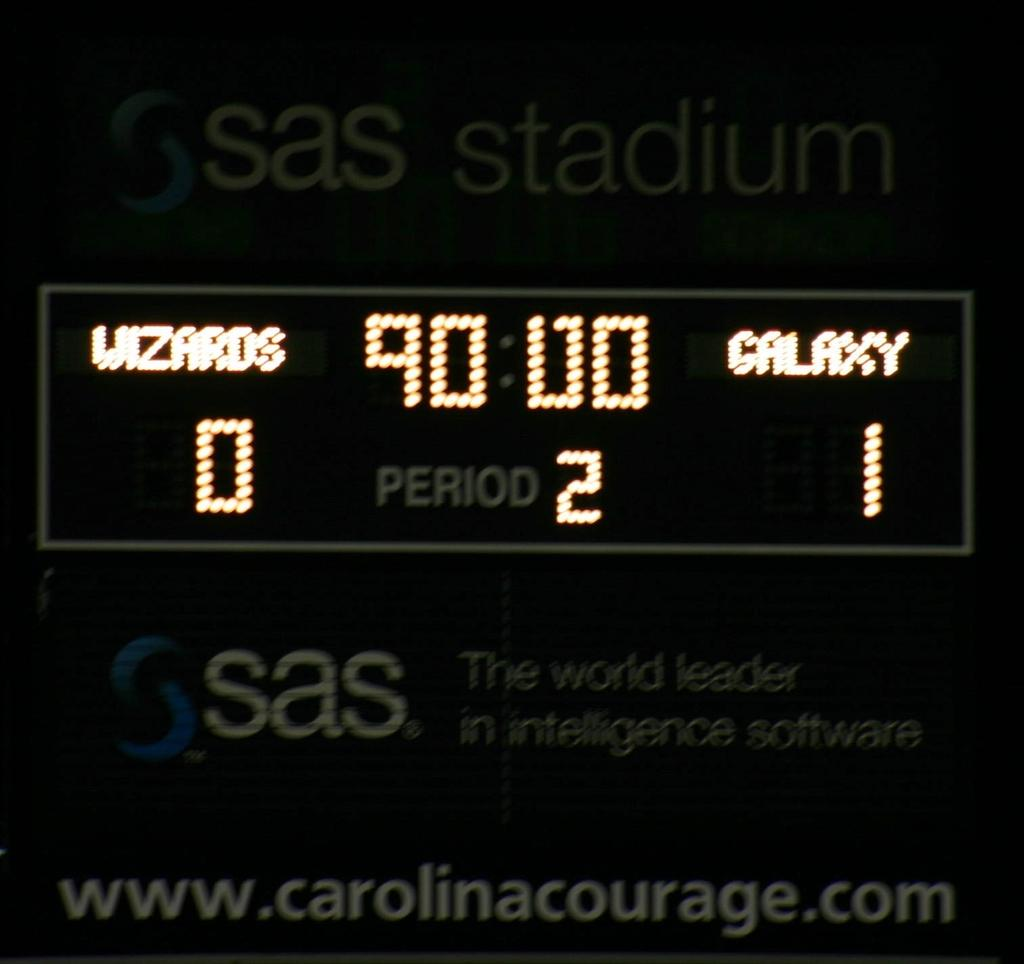Provide a one-sentence caption for the provided image. a scoreboard that has the number 2 on it. 